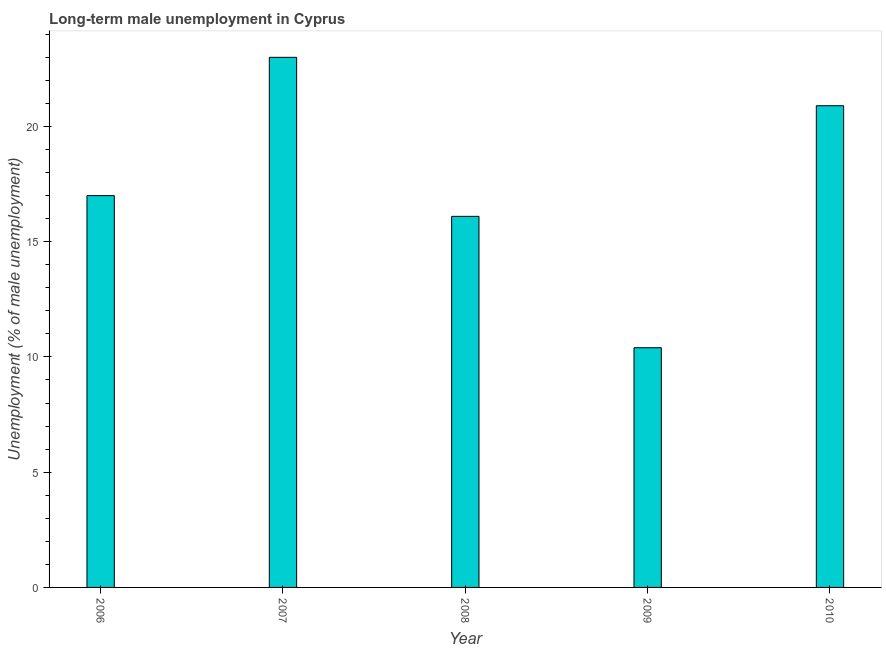What is the title of the graph?
Make the answer very short. Long-term male unemployment in Cyprus. What is the label or title of the X-axis?
Give a very brief answer. Year. What is the label or title of the Y-axis?
Give a very brief answer. Unemployment (% of male unemployment). What is the long-term male unemployment in 2008?
Keep it short and to the point. 16.1. Across all years, what is the minimum long-term male unemployment?
Ensure brevity in your answer.  10.4. In which year was the long-term male unemployment maximum?
Give a very brief answer. 2007. What is the sum of the long-term male unemployment?
Keep it short and to the point. 87.4. What is the average long-term male unemployment per year?
Offer a terse response. 17.48. What is the median long-term male unemployment?
Ensure brevity in your answer.  17. What is the ratio of the long-term male unemployment in 2007 to that in 2009?
Offer a very short reply. 2.21. Is the difference between the long-term male unemployment in 2006 and 2007 greater than the difference between any two years?
Offer a terse response. No. How many bars are there?
Your answer should be compact. 5. Are all the bars in the graph horizontal?
Your answer should be compact. No. How many years are there in the graph?
Your response must be concise. 5. What is the Unemployment (% of male unemployment) in 2007?
Keep it short and to the point. 23. What is the Unemployment (% of male unemployment) of 2008?
Offer a very short reply. 16.1. What is the Unemployment (% of male unemployment) of 2009?
Keep it short and to the point. 10.4. What is the Unemployment (% of male unemployment) in 2010?
Ensure brevity in your answer.  20.9. What is the difference between the Unemployment (% of male unemployment) in 2007 and 2008?
Provide a succinct answer. 6.9. What is the ratio of the Unemployment (% of male unemployment) in 2006 to that in 2007?
Your answer should be compact. 0.74. What is the ratio of the Unemployment (% of male unemployment) in 2006 to that in 2008?
Offer a terse response. 1.06. What is the ratio of the Unemployment (% of male unemployment) in 2006 to that in 2009?
Provide a succinct answer. 1.64. What is the ratio of the Unemployment (% of male unemployment) in 2006 to that in 2010?
Offer a terse response. 0.81. What is the ratio of the Unemployment (% of male unemployment) in 2007 to that in 2008?
Offer a very short reply. 1.43. What is the ratio of the Unemployment (% of male unemployment) in 2007 to that in 2009?
Your response must be concise. 2.21. What is the ratio of the Unemployment (% of male unemployment) in 2007 to that in 2010?
Offer a very short reply. 1.1. What is the ratio of the Unemployment (% of male unemployment) in 2008 to that in 2009?
Make the answer very short. 1.55. What is the ratio of the Unemployment (% of male unemployment) in 2008 to that in 2010?
Your answer should be compact. 0.77. What is the ratio of the Unemployment (% of male unemployment) in 2009 to that in 2010?
Offer a terse response. 0.5. 